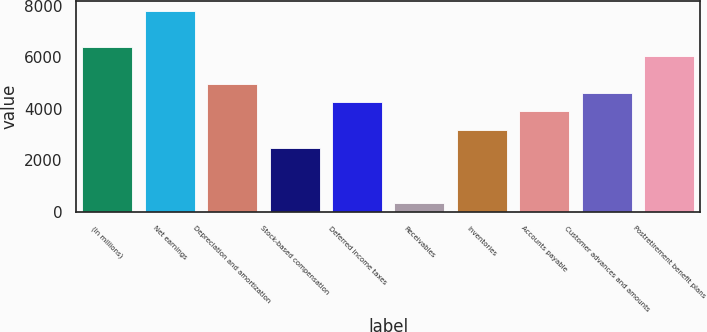<chart> <loc_0><loc_0><loc_500><loc_500><bar_chart><fcel>(In millions)<fcel>Net earnings<fcel>Depreciation and amortization<fcel>Stock-based compensation<fcel>Deferred income taxes<fcel>Receivables<fcel>Inventories<fcel>Accounts payable<fcel>Customer advances and amounts<fcel>Postretirement benefit plans<nl><fcel>6380.6<fcel>7797.4<fcel>4963.8<fcel>2484.4<fcel>4255.4<fcel>359.2<fcel>3192.8<fcel>3901.2<fcel>4609.6<fcel>6026.4<nl></chart> 